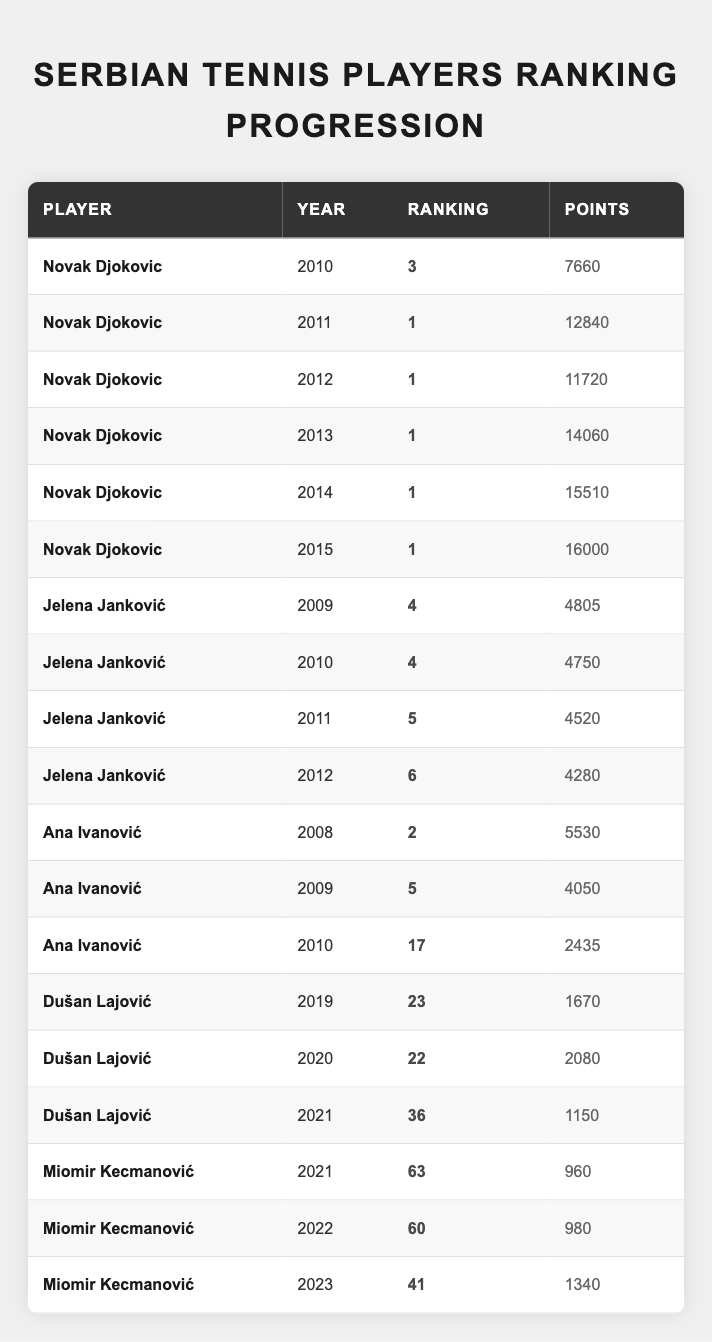What was Novak Djokovic's ranking in 2014? Referring to the table, Novak Djokovic's ranking in the year 2014 is listed as 1.
Answer: 1 What is the highest number of points Jelena Janković had recorded from 2009 to 2012? In the table, Jelena Janković recorded 4805 points in 2009, 4750 in 2010, 4520 in 2011, and 4280 in 2012. The highest value among these is 4805 points.
Answer: 4805 Did Ana Ivanović ever rank higher than 5 between 2008 and 2010? By checking the table, Ana Ivanović's rankings were 2 in 2008, 5 in 2009, and then dropped to 17 in 2010. Therefore, she did rank higher than 5 in 2008.
Answer: Yes Which player had the most points in 2015 and what was that score? Looking at the table, Novak Djokovic is the only player listed for 2015 and he had 16000 points. Therefore, he had the most points in that year.
Answer: 16000 What was the average ranking of Dušan Lajović from 2019 to 2021? Dušan Lajović's rankings for 2019, 2020, and 2021 were 23, 22, and 36 respectively. The average is calculated by summing these rankings (23 + 22 + 36 = 81) and then dividing by 3, which gives an average of 27.
Answer: 27 Which Serbian player showed consistent improvement in ranking from 2021 to 2023? From the table, Miomir Kecmanović improved his ranking from 63 in 2021 to 60 in 2022, and then to 41 in 2023, indicating consistent improvement over those years.
Answer: Miomir Kecmanović What year did Ana Ivanović achieve her lowest ranking? According to the table, Ana Ivanović's lowest ranking was 17 in 2010, which is the only year listed with that rank.
Answer: 2010 How many points did Dušan Lajović accumulate in 2021 as compared to the previous year? Dušan Lajović had 2080 points in 2020 and dropped to 1150 points in 2021. The difference is calculated as 2080 - 1150 = 930 points.
Answer: 930 Is it true that Jelena Janković's ranking declined every year from 2009 to 2012? Looking at the rankings, Janković was ranked 4 in 2009, 4 in 2010, 5 in 2011, and 6 in 2012. Since she maintained the same rank in 2010, the answer is no, her ranking did not decline every year.
Answer: No What was the total points collected by Novak Djokovic from 2010 to 2015? The points are 7660 (2010) + 12840 (2011) + 11720 (2012) + 14060 (2013) + 15510 (2014) + 16000 (2015) = 7660 + 12840 + 11720 + 14060 + 15510 + 16000 = 88590 points.
Answer: 88590 